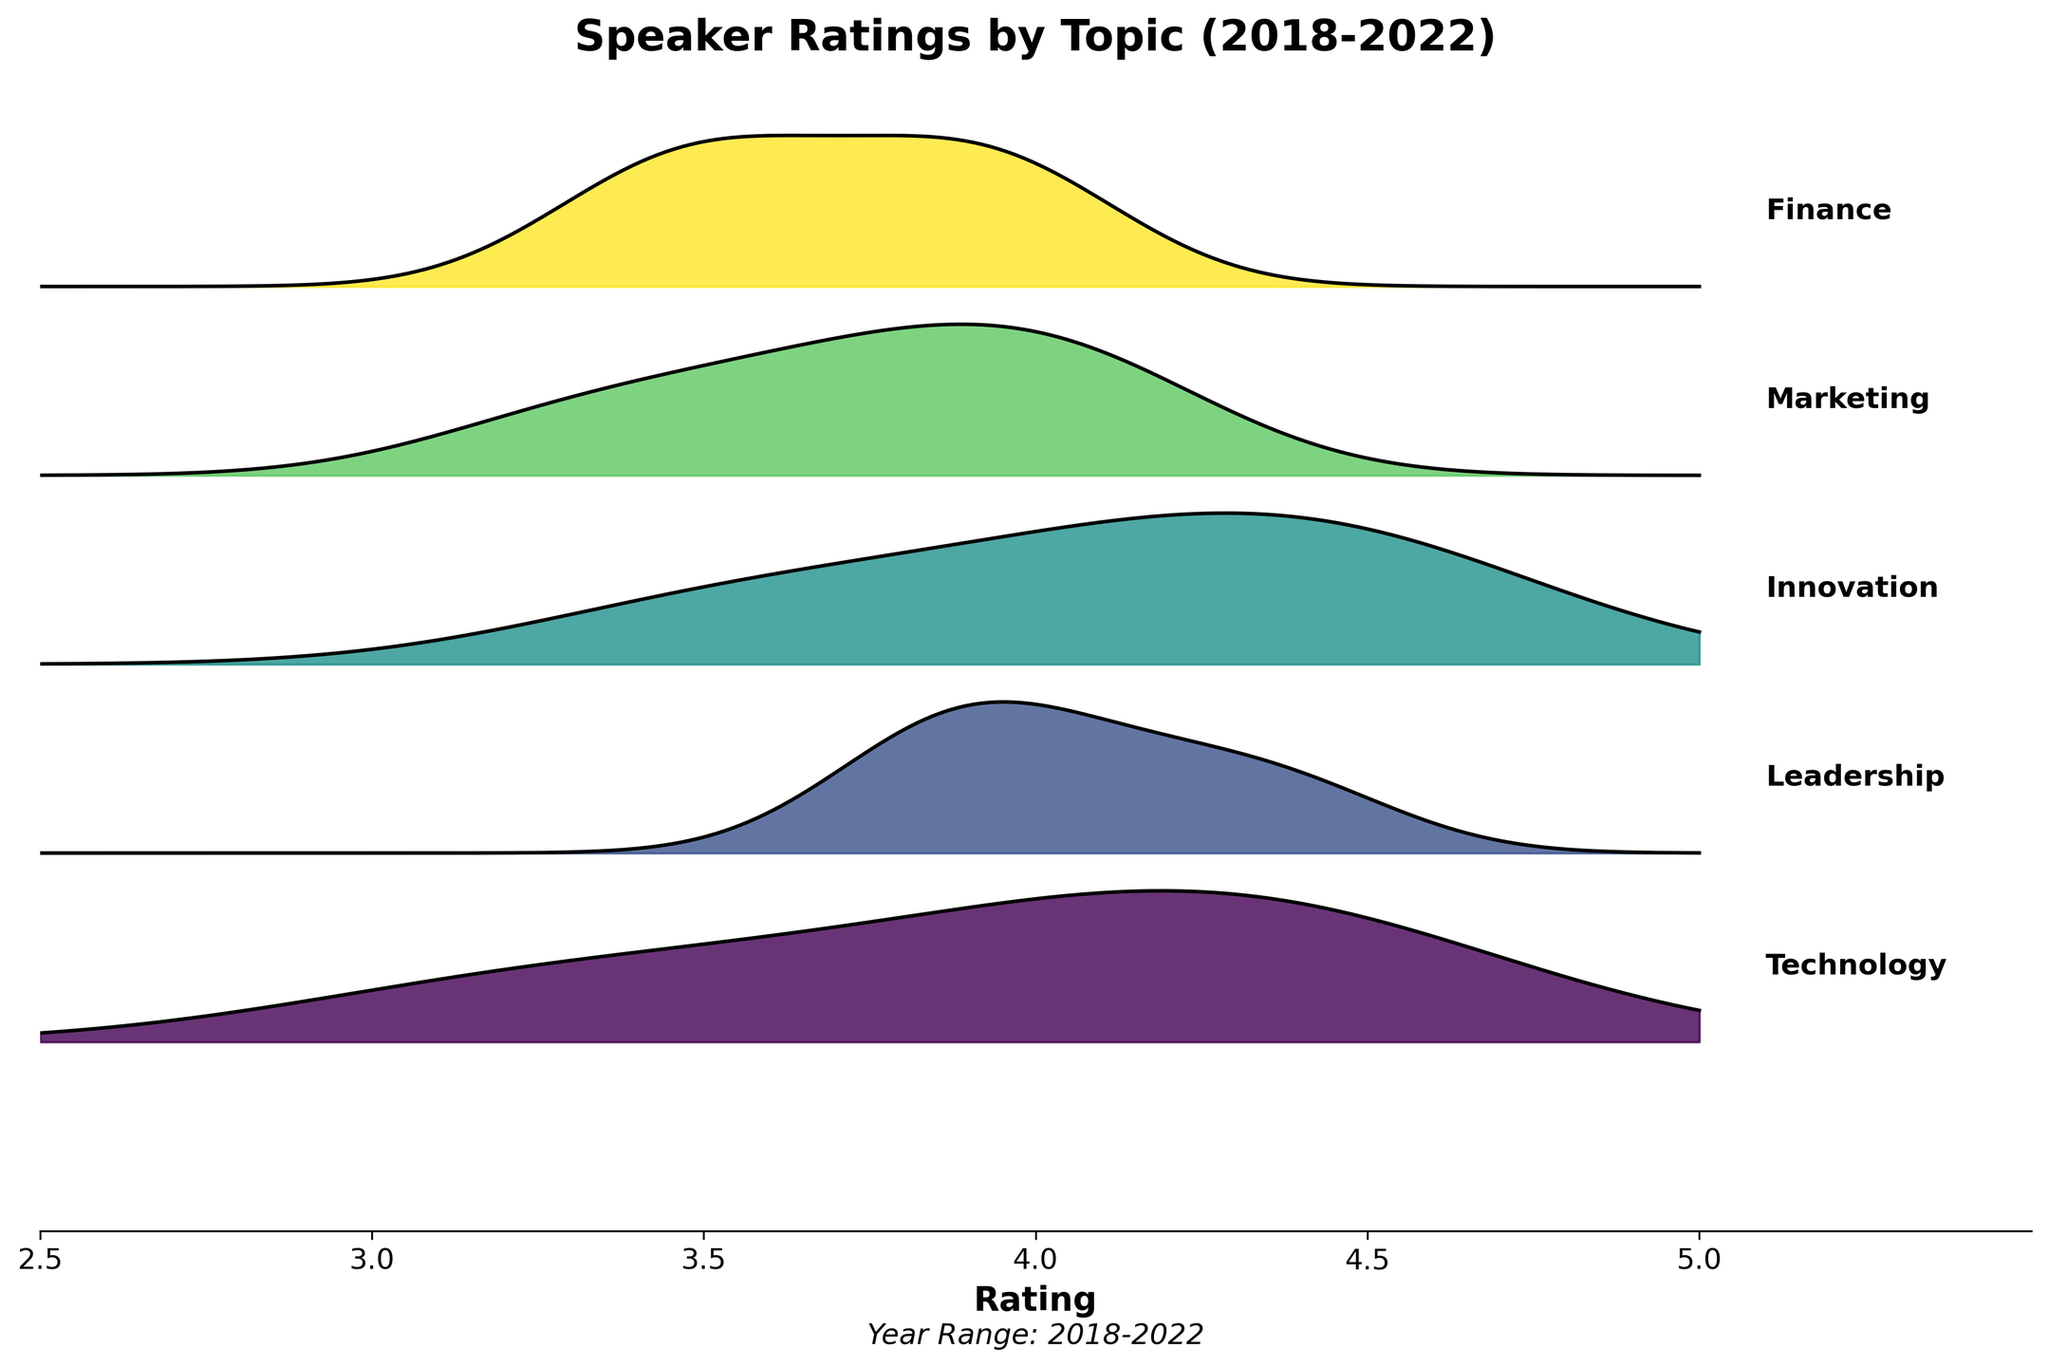what is the title of the plot? The title appears prominently at the top of the plot, which is "Speaker Ratings by Topic (2018-2022)".
Answer: Speaker Ratings by Topic (2018-2022) What is the highest rating across all topics? The rightmost point of the x-axis indicates that the maximum rating is 5.0. However, no density peak reaches 5.0, so the highest significant rating is 4.6 for Innovation in 2022.
Answer: 4.6 Which topic has the most consistent ratings over the years? To determine this, we observe the width of the distribution (how spread out the ratings are) for each topic. "Finance" has relatively flat and consistent distributions, meaning less variation in ratings.
Answer: Finance Which topic showed the greatest improvement in ratings from 2018 to 2022? Evaluating the change in peak positions of the ratings distribution from 2018 to 2022 reveals that "Innovation" showed the greatest improvement, moving from 3.5 to 4.6.
Answer: Innovation What is the approximate average rating for Technology in 2020? Identify the peak for Technology in 2020 on the ridgeline plot, which is approximately at 4.1.
Answer: 4.1 How did the ratings for Marketing change between 2020 and 2021? Compare the peaks for Marketing in both years: 3.8 (2020) to 4.0 (2021), indicating an increase.
Answer: Increased Which topic had the lowest rating in 2018? Among the distributions for 2018, the leftmost peak belongs to "Technology" at approximately 3.2.
Answer: Technology How many topics saw their ratings increase every year from 2018 to 2022? Evaluating each topic’s progression, "Technology," "Innovation," "Leadership," and "Finance" saw consistent yearly increases.
Answer: 4 Which topic’s rating did not improve much from 2018 to 2022 compared to others? Observing the density plots, "Finance" has seen the least improvement relatively, moving from 3.4 to 4.0.
Answer: Finance 